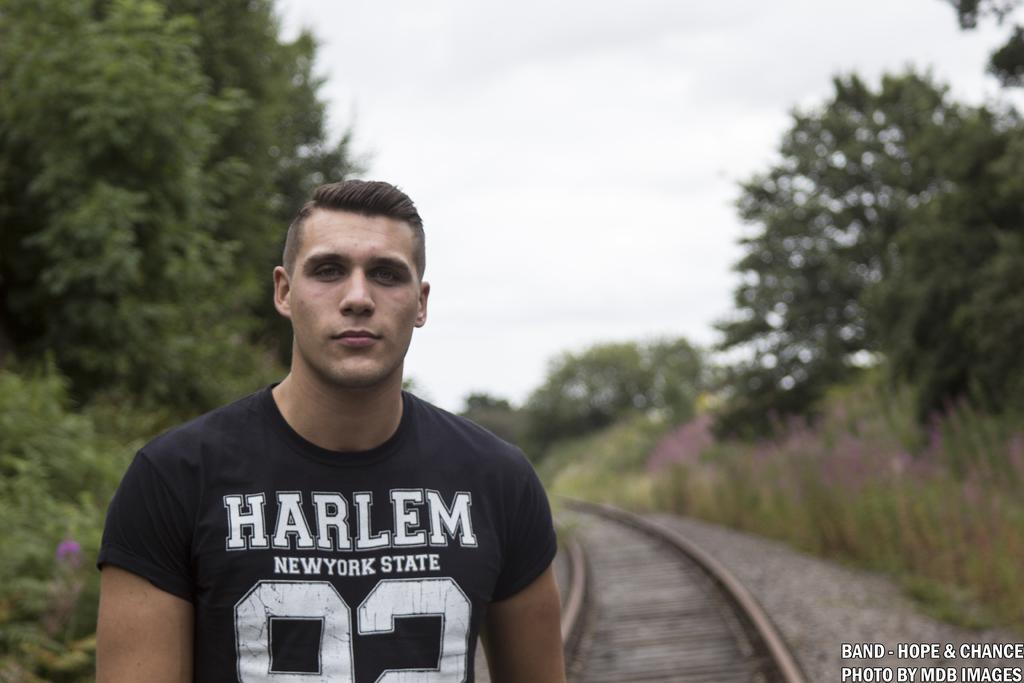In one or two sentences, can you explain what this image depicts? In this image I can see there is a man standing and there are railway tracks in the background. There are plants, trees and the sky is clear, the background of the image is blurred. 